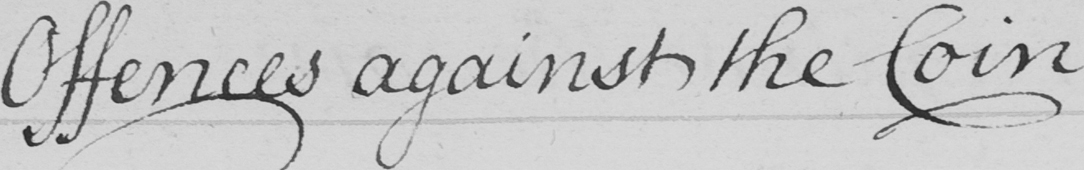Please provide the text content of this handwritten line. Offences against the Coin 